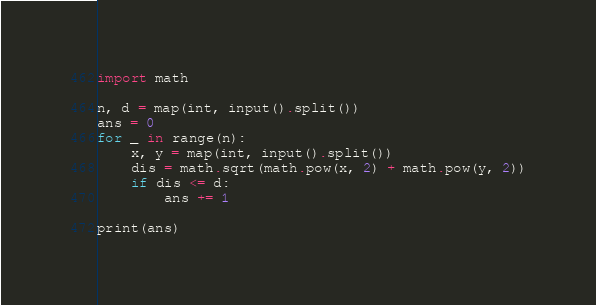<code> <loc_0><loc_0><loc_500><loc_500><_Python_>import math

n, d = map(int, input().split())
ans = 0
for _ in range(n):
    x, y = map(int, input().split())
    dis = math.sqrt(math.pow(x, 2) + math.pow(y, 2))
    if dis <= d:
        ans += 1

print(ans)
</code> 